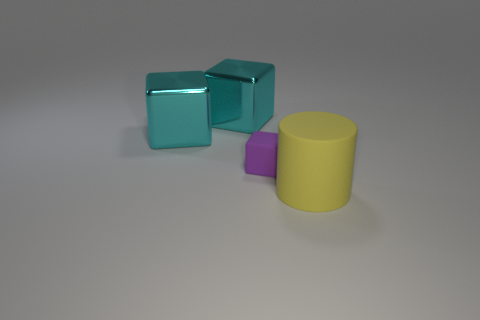Can you tell me the colors of the objects in the image? Certainly, the image features objects in three distinct colors: there's a pair of teal-colored cubes, a tiny purple cube, and a yellow cylinder. 